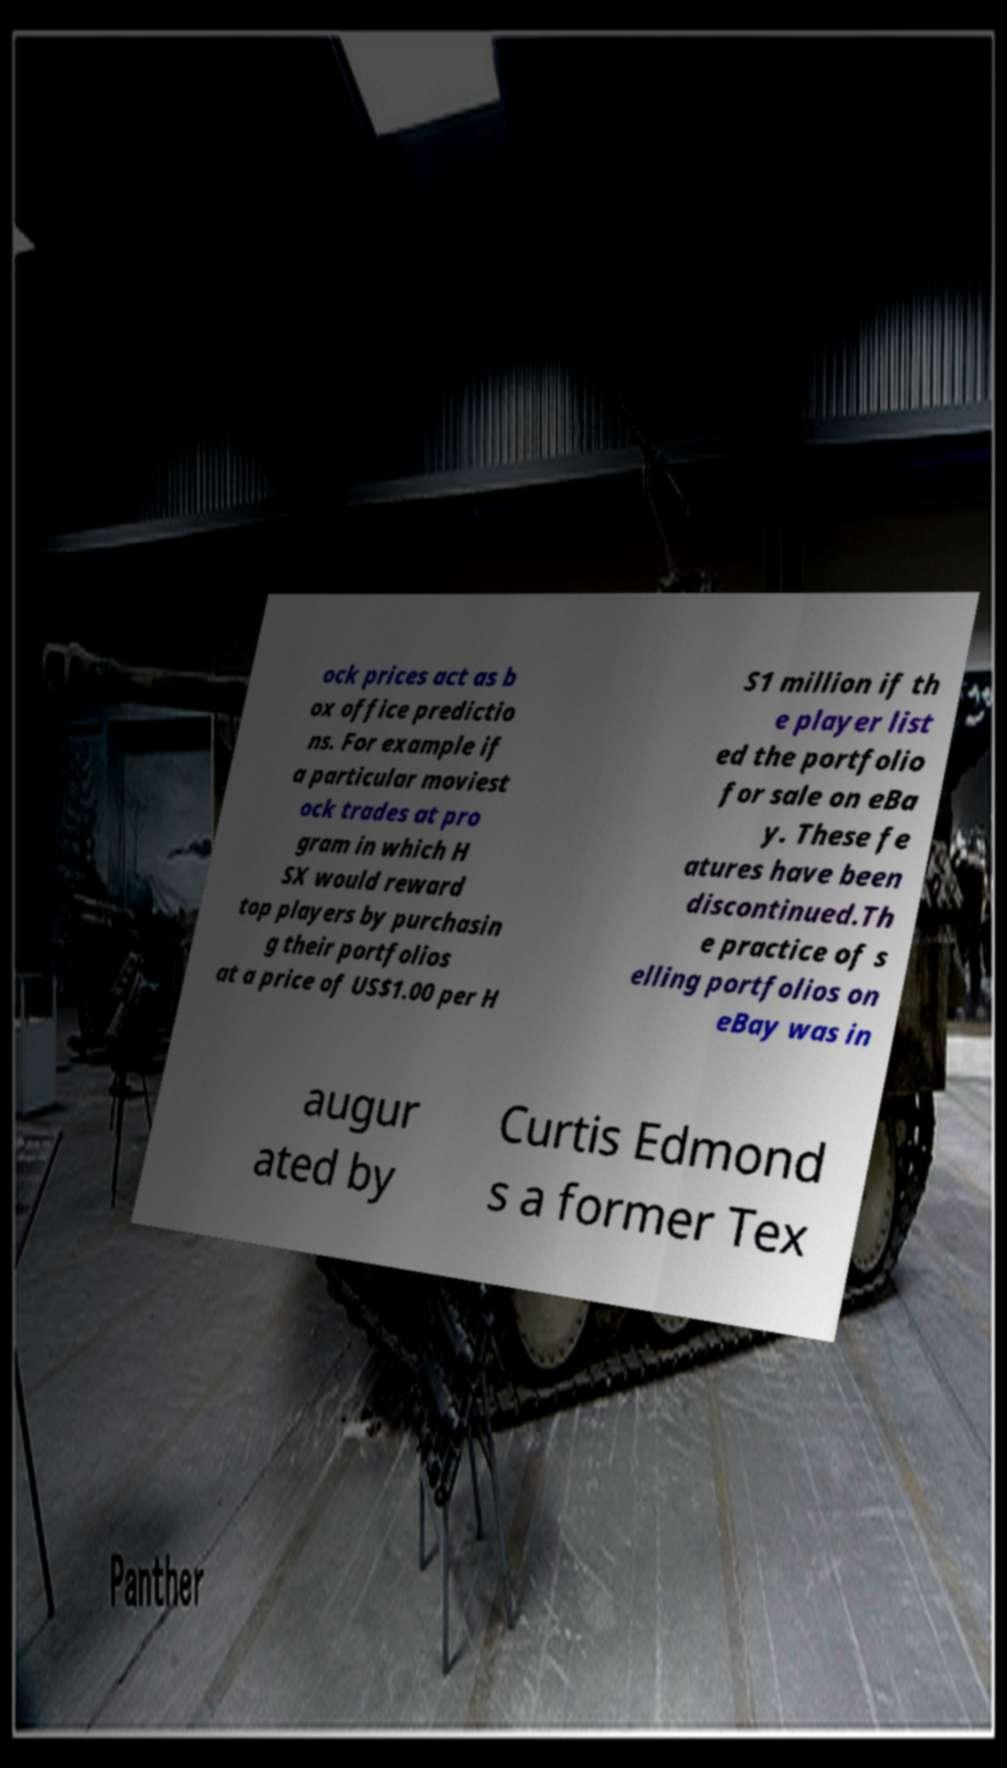Can you accurately transcribe the text from the provided image for me? ock prices act as b ox office predictio ns. For example if a particular moviest ock trades at pro gram in which H SX would reward top players by purchasin g their portfolios at a price of US$1.00 per H S1 million if th e player list ed the portfolio for sale on eBa y. These fe atures have been discontinued.Th e practice of s elling portfolios on eBay was in augur ated by Curtis Edmond s a former Tex 